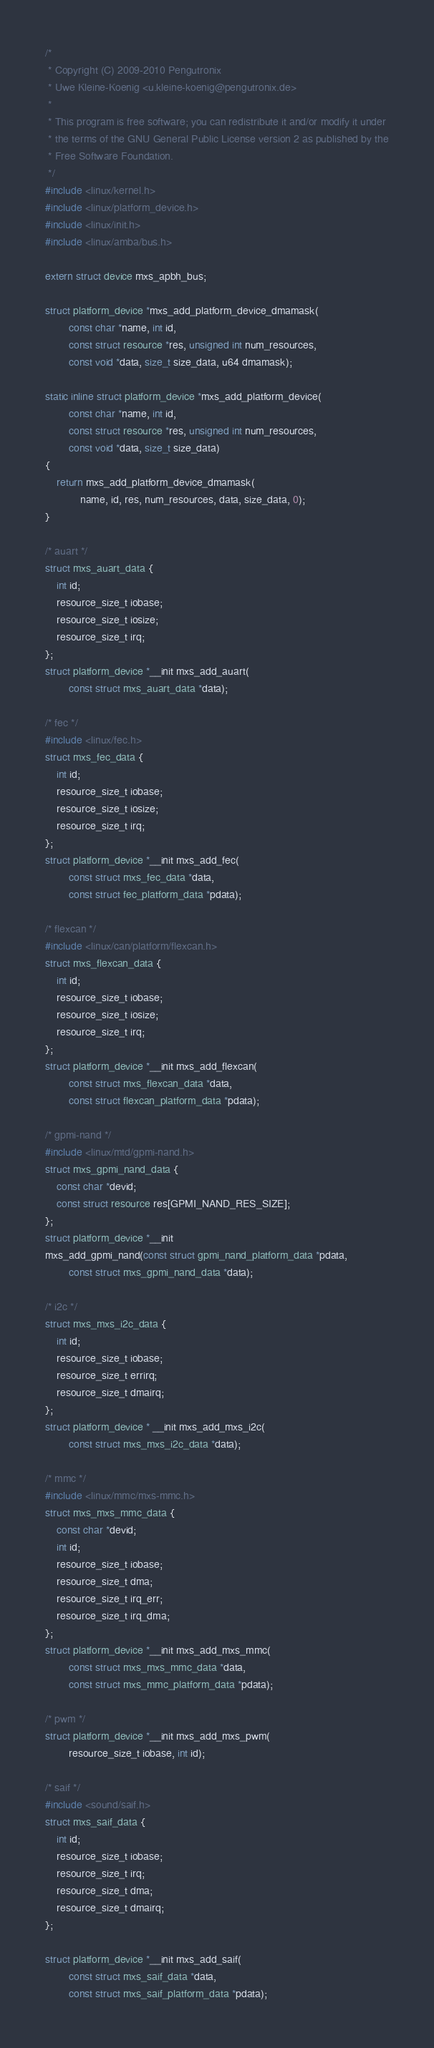Convert code to text. <code><loc_0><loc_0><loc_500><loc_500><_C_>/*
 * Copyright (C) 2009-2010 Pengutronix
 * Uwe Kleine-Koenig <u.kleine-koenig@pengutronix.de>
 *
 * This program is free software; you can redistribute it and/or modify it under
 * the terms of the GNU General Public License version 2 as published by the
 * Free Software Foundation.
 */
#include <linux/kernel.h>
#include <linux/platform_device.h>
#include <linux/init.h>
#include <linux/amba/bus.h>

extern struct device mxs_apbh_bus;

struct platform_device *mxs_add_platform_device_dmamask(
		const char *name, int id,
		const struct resource *res, unsigned int num_resources,
		const void *data, size_t size_data, u64 dmamask);

static inline struct platform_device *mxs_add_platform_device(
		const char *name, int id,
		const struct resource *res, unsigned int num_resources,
		const void *data, size_t size_data)
{
	return mxs_add_platform_device_dmamask(
			name, id, res, num_resources, data, size_data, 0);
}

/* auart */
struct mxs_auart_data {
	int id;
	resource_size_t iobase;
	resource_size_t iosize;
	resource_size_t irq;
};
struct platform_device *__init mxs_add_auart(
		const struct mxs_auart_data *data);

/* fec */
#include <linux/fec.h>
struct mxs_fec_data {
	int id;
	resource_size_t iobase;
	resource_size_t iosize;
	resource_size_t irq;
};
struct platform_device *__init mxs_add_fec(
		const struct mxs_fec_data *data,
		const struct fec_platform_data *pdata);

/* flexcan */
#include <linux/can/platform/flexcan.h>
struct mxs_flexcan_data {
	int id;
	resource_size_t iobase;
	resource_size_t iosize;
	resource_size_t irq;
};
struct platform_device *__init mxs_add_flexcan(
		const struct mxs_flexcan_data *data,
		const struct flexcan_platform_data *pdata);

/* gpmi-nand */
#include <linux/mtd/gpmi-nand.h>
struct mxs_gpmi_nand_data {
	const char *devid;
	const struct resource res[GPMI_NAND_RES_SIZE];
};
struct platform_device *__init
mxs_add_gpmi_nand(const struct gpmi_nand_platform_data *pdata,
		const struct mxs_gpmi_nand_data *data);

/* i2c */
struct mxs_mxs_i2c_data {
	int id;
	resource_size_t iobase;
	resource_size_t errirq;
	resource_size_t dmairq;
};
struct platform_device * __init mxs_add_mxs_i2c(
		const struct mxs_mxs_i2c_data *data);

/* mmc */
#include <linux/mmc/mxs-mmc.h>
struct mxs_mxs_mmc_data {
	const char *devid;
	int id;
	resource_size_t iobase;
	resource_size_t dma;
	resource_size_t irq_err;
	resource_size_t irq_dma;
};
struct platform_device *__init mxs_add_mxs_mmc(
		const struct mxs_mxs_mmc_data *data,
		const struct mxs_mmc_platform_data *pdata);

/* pwm */
struct platform_device *__init mxs_add_mxs_pwm(
		resource_size_t iobase, int id);

/* saif */
#include <sound/saif.h>
struct mxs_saif_data {
	int id;
	resource_size_t iobase;
	resource_size_t irq;
	resource_size_t dma;
	resource_size_t dmairq;
};

struct platform_device *__init mxs_add_saif(
		const struct mxs_saif_data *data,
		const struct mxs_saif_platform_data *pdata);
</code> 